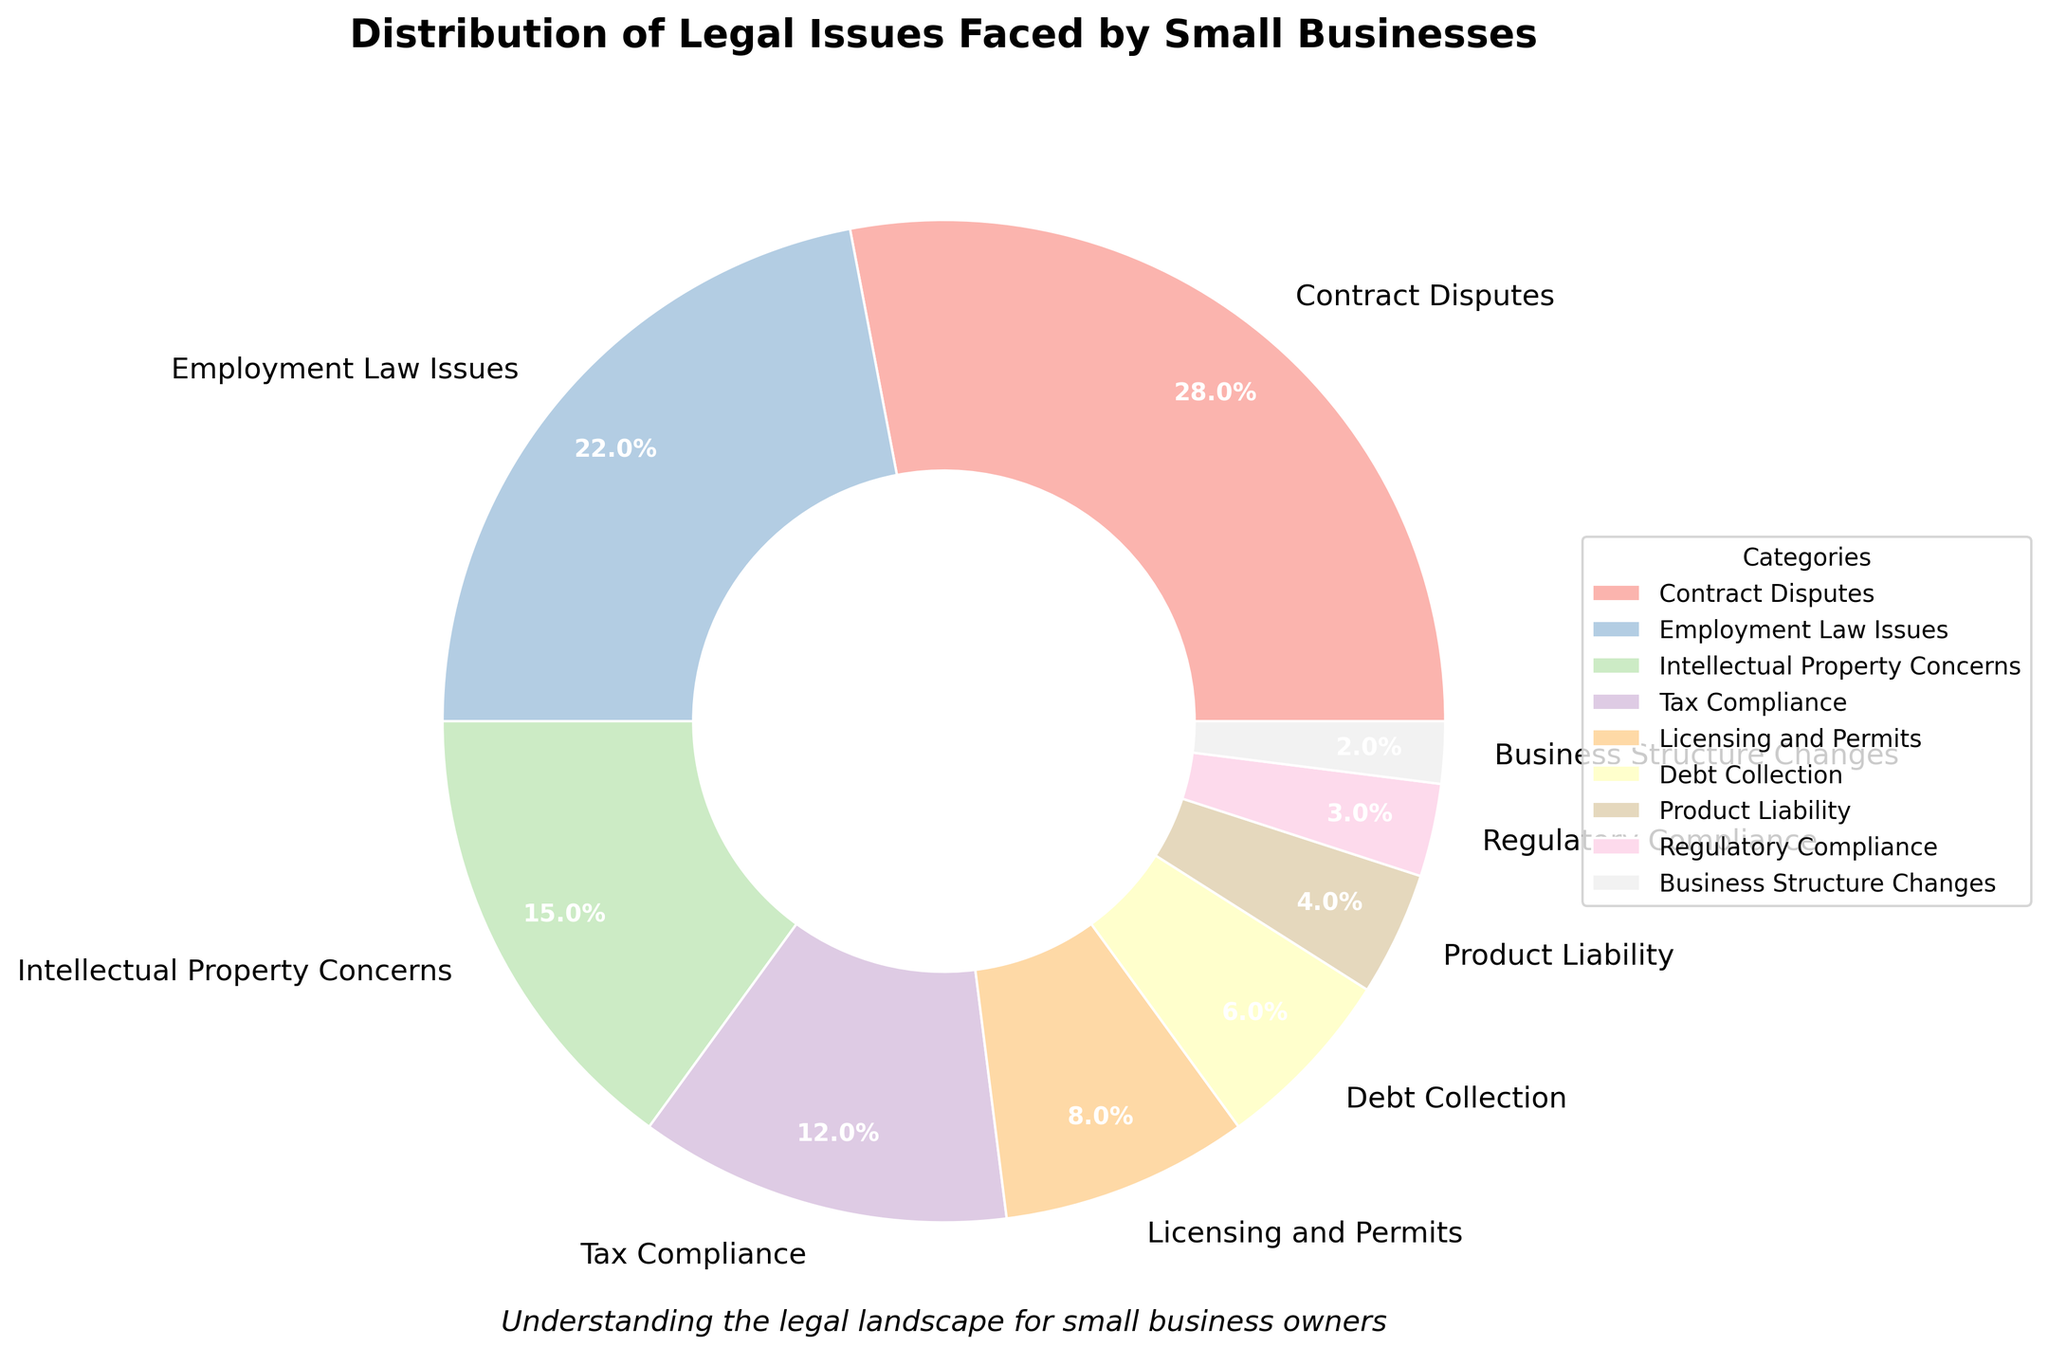Which legal issue is the most common among small businesses? The pie chart shows various legal issues with their respective percentages. The category with the highest percentage value represents the most common issue. In this case, "Contract Disputes" has the highest value at 28%.
Answer: Contract Disputes What is the combined percentage of Employment Law Issues and Intellectual Property Concerns? Sum the percentages of Employment Law Issues (22%) and Intellectual Property Concerns (15%). The combined percentage is 22% + 15% = 37%.
Answer: 37% How many legal issues have a percentage below 10%? Identify the categories with percentages lower than 10%. These are Licensing and Permits (8%), Debt Collection (6%), Product Liability (4%), Regulatory Compliance (3%), and Business Structure Changes (2%). There are 5 such issues.
Answer: 5 Which category has a smaller percentage, Tax Compliance or Licensing and Permits? Compare the percentages of Tax Compliance (12%) and Licensing and Permits (8%). Licensing and Permits has a smaller percentage.
Answer: Licensing and Permits By how much does Contract Disputes' percentage exceed that of Debt Collection? Subtract the percentage of Debt Collection (6%) from that of Contract Disputes (28%). The difference is 28% - 6% = 22%.
Answer: 22% What is the percentage difference between the least common and the most common legal issues? Identify the least common issue (Business Structure Changes at 2%) and the most common issue (Contract Disputes at 28%). The difference is 28% - 2% = 26%.
Answer: 26% Which categories fall between 10% to 20% in terms of their percentages? Check the categories whose percentages lie within the 10% to 20% range. These categories are Intellectual Property Concerns (15%) and Tax Compliance (12%).
Answer: Intellectual Property Concerns, Tax Compliance Which two categories contribute least to the overall legal issues faced by small businesses? Identify the categories with the smallest percentages. Regulatory Compliance (3%) and Business Structure Changes (2%) contribute the least.
Answer: Regulatory Compliance, Business Structure Changes What proportion of the total legal issues do Debt Collection and Product Liability together represent? Sum the percentages of Debt Collection (6%) and Product Liability (4%). The combined proportion is 6% + 4% = 10%.
Answer: 10% If you combine Licensing and Permits, Debt Collection, and Product Liability, what percentage do they represent together? Sum the percentages for Licensing and Permits (8%), Debt Collection (6%), and Product Liability (4%). The combined percentage is 8% + 6% + 4% = 18%.
Answer: 18% 